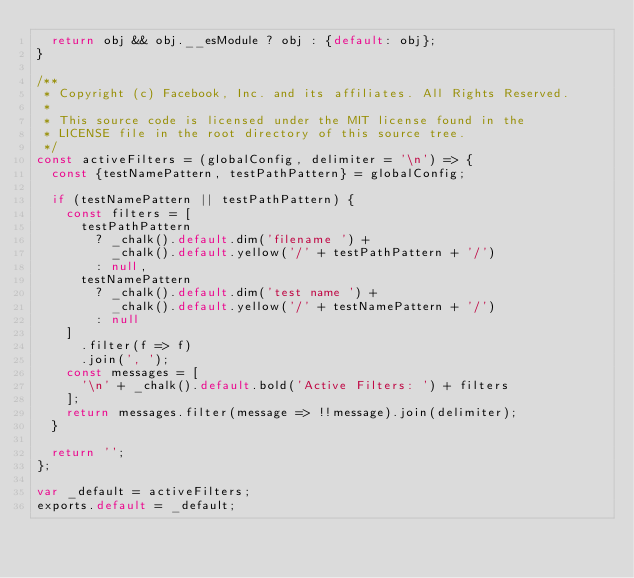Convert code to text. <code><loc_0><loc_0><loc_500><loc_500><_JavaScript_>  return obj && obj.__esModule ? obj : {default: obj};
}

/**
 * Copyright (c) Facebook, Inc. and its affiliates. All Rights Reserved.
 *
 * This source code is licensed under the MIT license found in the
 * LICENSE file in the root directory of this source tree.
 */
const activeFilters = (globalConfig, delimiter = '\n') => {
  const {testNamePattern, testPathPattern} = globalConfig;

  if (testNamePattern || testPathPattern) {
    const filters = [
      testPathPattern
        ? _chalk().default.dim('filename ') +
          _chalk().default.yellow('/' + testPathPattern + '/')
        : null,
      testNamePattern
        ? _chalk().default.dim('test name ') +
          _chalk().default.yellow('/' + testNamePattern + '/')
        : null
    ]
      .filter(f => f)
      .join(', ');
    const messages = [
      '\n' + _chalk().default.bold('Active Filters: ') + filters
    ];
    return messages.filter(message => !!message).join(delimiter);
  }

  return '';
};

var _default = activeFilters;
exports.default = _default;
</code> 